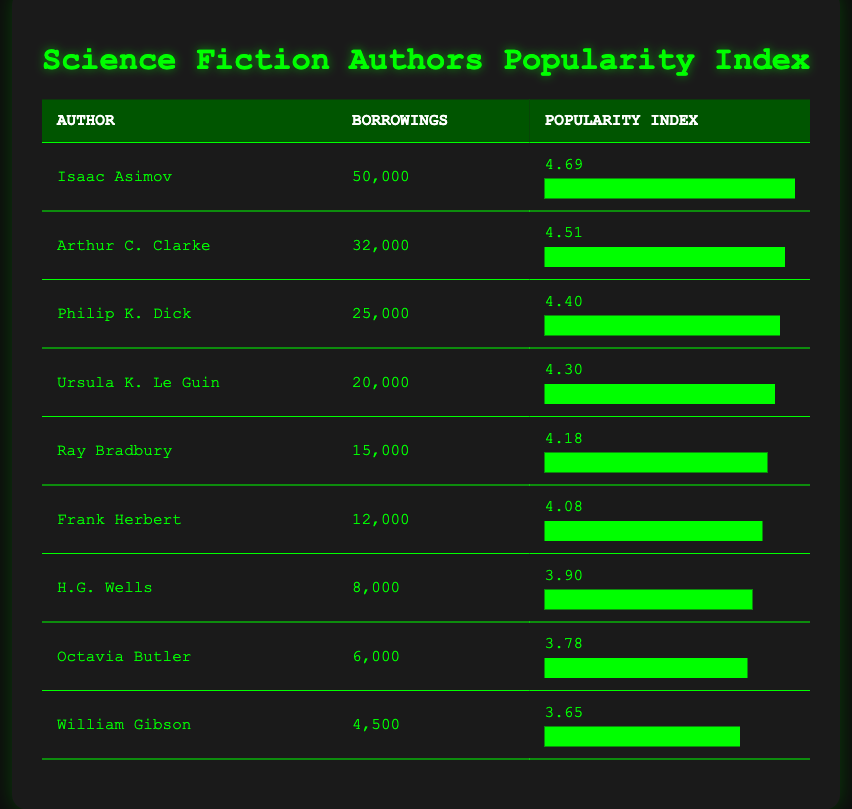What is the most borrowed science fiction book author? According to the table, Isaac Asimov has the highest number of borrowings, with 50,000.
Answer: Isaac Asimov What is the popularity index of Ursula K. Le Guin? The table displays that Ursula K. Le Guin has a popularity index of 4.30.
Answer: 4.30 Is Ray Bradbury more popular than H.G. Wells? Ray Bradbury has a popularity index of 4.18, whereas H.G. Wells has a popularity index of 3.90; thus, Ray Bradbury is indeed more popular.
Answer: Yes What is the total number of borrowings for the top three authors? The total borrowings for the top three authors (Isaac Asimov, Arthur C. Clarke, and Philip K. Dick) are 50,000 + 32,000 + 25,000 = 107,000.
Answer: 107,000 Which author has the lowest popularity index, and what is that index? William Gibson has the lowest popularity index at 3.65, as shown in the table.
Answer: 3.65 Does Philip K. Dick have more borrowings than Frank Herbert? Philip K. Dick has 25,000 borrowings, while Frank Herbert has 12,000; hence, Philip K. Dick has more borrowings.
Answer: Yes What is the average popularity index of the authors listed? To find the average, we sum all the popularity indices (4.69 + 4.51 + 4.40 + 4.30 + 4.18 + 4.08 + 3.90 + 3.78 + 3.65 = 37.49) and divide by the number of authors (9), resulting in 37.49/9 = 4.16.
Answer: 4.16 Who has more borrowings, Octavia Butler or H.G. Wells? Octavia Butler has 6,000 borrowings and H.G. Wells has 8,000 borrowings; thus, H.G. Wells has more borrowings.
Answer: H.G. Wells Calculate the difference in borrowings between the most and least popular authors. Isaac Asimov has 50,000 borrowings and William Gibson has 4,500; the difference is 50,000 - 4,500 = 45,500.
Answer: 45,500 